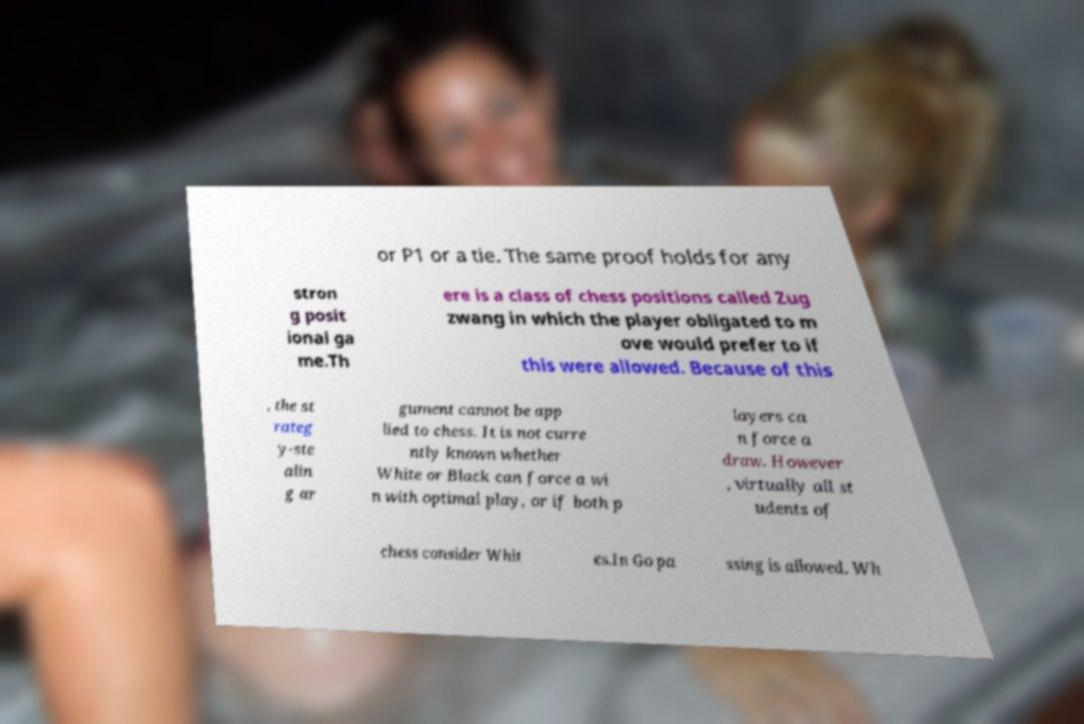Can you read and provide the text displayed in the image?This photo seems to have some interesting text. Can you extract and type it out for me? or P1 or a tie. The same proof holds for any stron g posit ional ga me.Th ere is a class of chess positions called Zug zwang in which the player obligated to m ove would prefer to if this were allowed. Because of this , the st rateg y-ste alin g ar gument cannot be app lied to chess. It is not curre ntly known whether White or Black can force a wi n with optimal play, or if both p layers ca n force a draw. However , virtually all st udents of chess consider Whit es.In Go pa ssing is allowed. Wh 